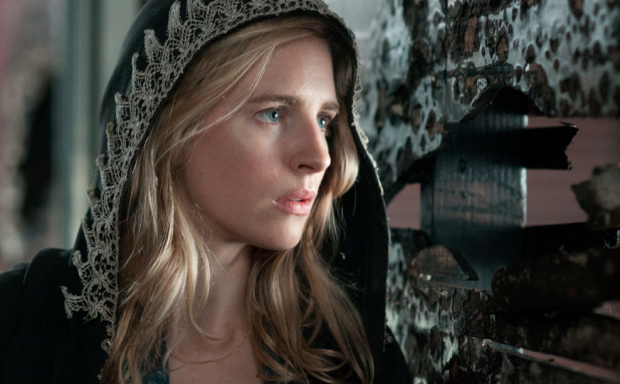What's happening in the scene? In the image, a character portrayed by an actress is seen clad in a black hooded cloak trimmed with white lace, emanating an aura of mystery. The character appears deeply absorbed in thought, her expression one of concern or worry, as she gazes off to the side, likely contemplating or anticipating something significant. The background features a wall with peeling black and white posters, contrasting sharply with her dark attire and adding an element of intrigue and suspense to the scene. The overall atmosphere suggests a narrative rich with tension and unfolding events. 